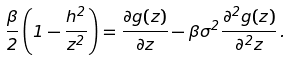<formula> <loc_0><loc_0><loc_500><loc_500>\frac { \beta } { 2 } \left ( 1 - \frac { h ^ { 2 } } { z ^ { 2 } } \right ) = \frac { \partial g ( z ) } { \partial z } - \beta \sigma ^ { 2 } \frac { \partial ^ { 2 } g ( z ) } { \partial ^ { 2 } z } \, .</formula> 